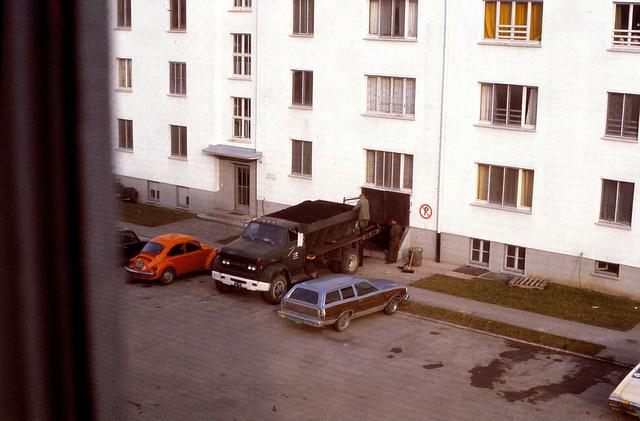Why is the truck backed up to the building? loading 